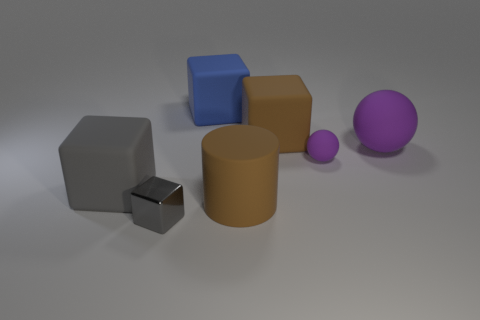What is the size of the gray block that is in front of the large matte block that is on the left side of the blue rubber cube? The gray block in question appears to be a small cube, proportionally much smaller than the large matte block and significantly smaller than the blue cube to the right. 